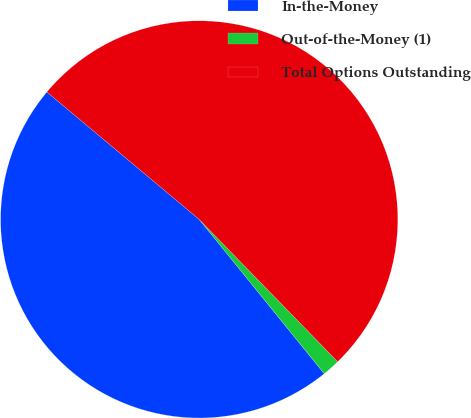Convert chart. <chart><loc_0><loc_0><loc_500><loc_500><pie_chart><fcel>In-the-Money<fcel>Out-of-the-Money (1)<fcel>Total Options Outstanding<nl><fcel>46.93%<fcel>1.44%<fcel>51.63%<nl></chart> 